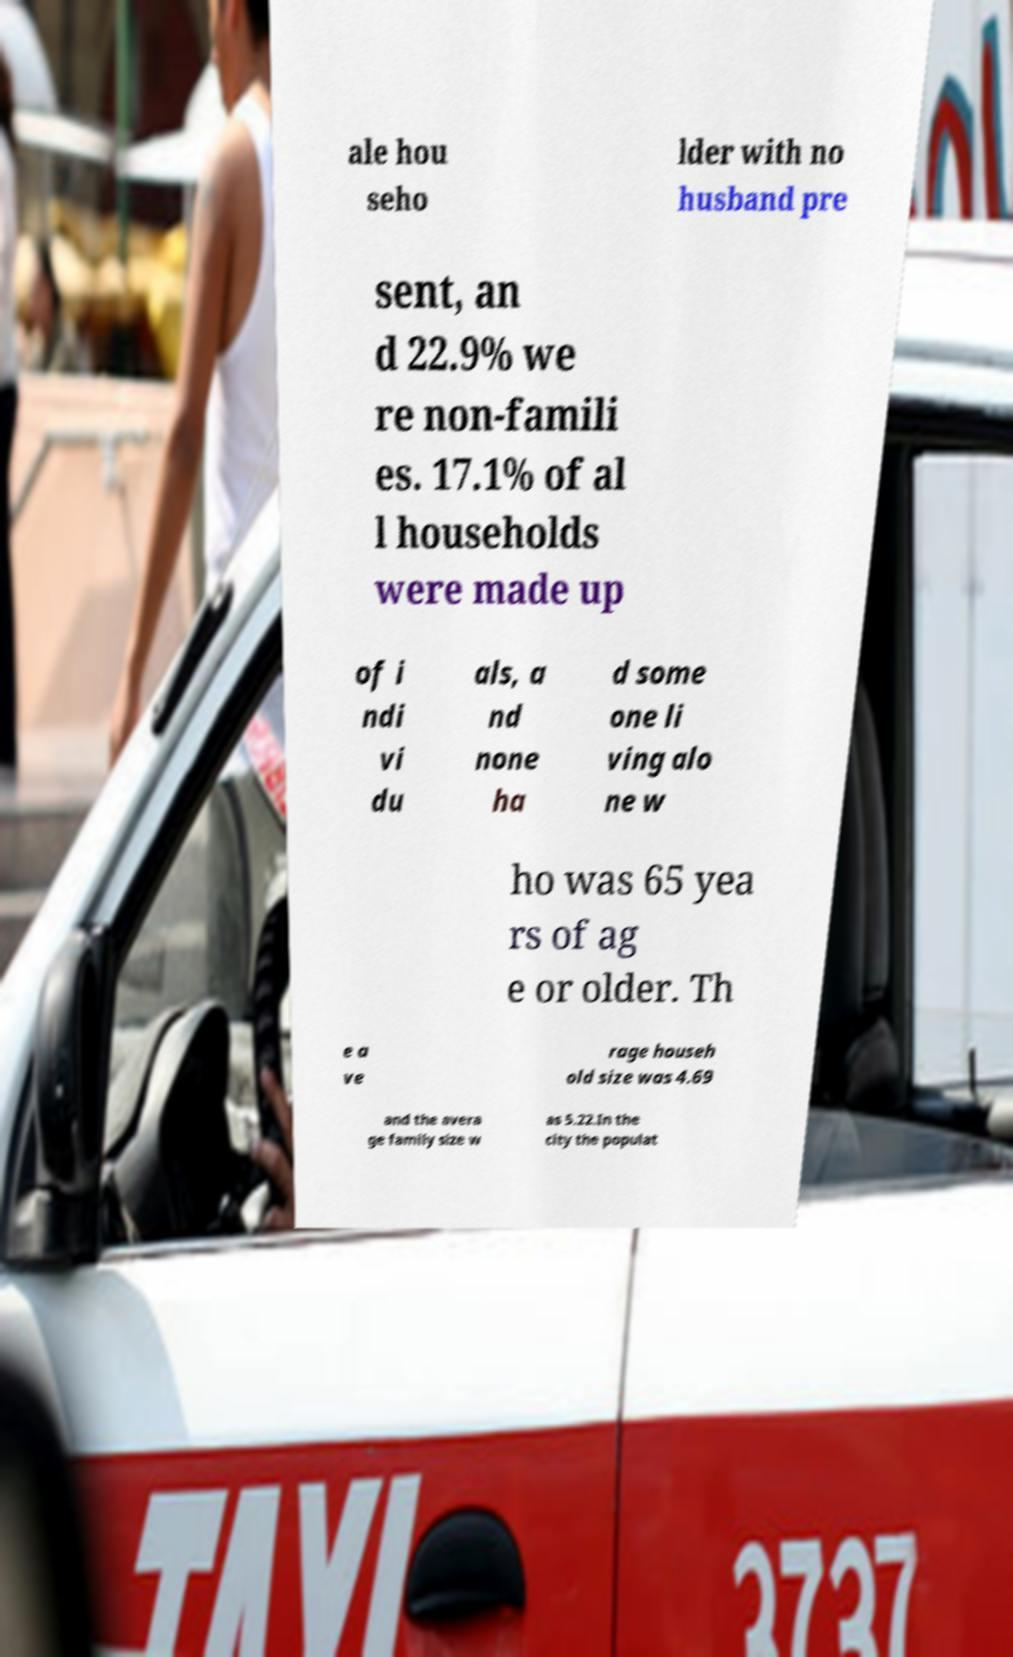Can you accurately transcribe the text from the provided image for me? ale hou seho lder with no husband pre sent, an d 22.9% we re non-famili es. 17.1% of al l households were made up of i ndi vi du als, a nd none ha d some one li ving alo ne w ho was 65 yea rs of ag e or older. Th e a ve rage househ old size was 4.69 and the avera ge family size w as 5.22.In the city the populat 